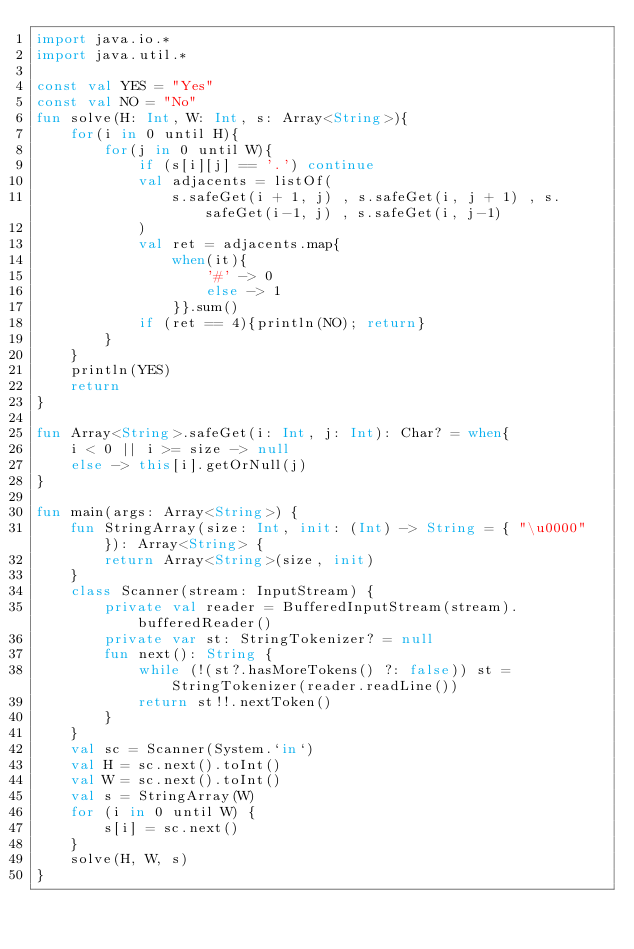<code> <loc_0><loc_0><loc_500><loc_500><_Kotlin_>import java.io.*
import java.util.*

const val YES = "Yes"
const val NO = "No"
fun solve(H: Int, W: Int, s: Array<String>){
    for(i in 0 until H){
        for(j in 0 until W){
            if (s[i][j] == '.') continue
            val adjacents = listOf(
                s.safeGet(i + 1, j) , s.safeGet(i, j + 1) , s.safeGet(i-1, j) , s.safeGet(i, j-1)
            )
            val ret = adjacents.map{
                when(it){
                    '#' -> 0
                    else -> 1
                }}.sum()
            if (ret == 4){println(NO); return}
        }
    }
    println(YES)
    return
}

fun Array<String>.safeGet(i: Int, j: Int): Char? = when{
    i < 0 || i >= size -> null
    else -> this[i].getOrNull(j)
}

fun main(args: Array<String>) {
    fun StringArray(size: Int, init: (Int) -> String = { "\u0000" }): Array<String> {
        return Array<String>(size, init)
    }
    class Scanner(stream: InputStream) {
        private val reader = BufferedInputStream(stream).bufferedReader()
        private var st: StringTokenizer? = null
        fun next(): String {
            while (!(st?.hasMoreTokens() ?: false)) st = StringTokenizer(reader.readLine())
            return st!!.nextToken()
        }
    }
    val sc = Scanner(System.`in`)
    val H = sc.next().toInt()
    val W = sc.next().toInt()
    val s = StringArray(W)
    for (i in 0 until W) {
        s[i] = sc.next()
    }
    solve(H, W, s)
}

</code> 